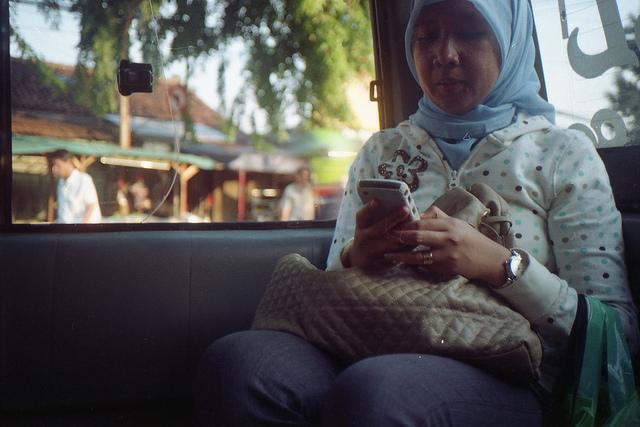What is one name for the type of headwear the woman is wearing? scarf 